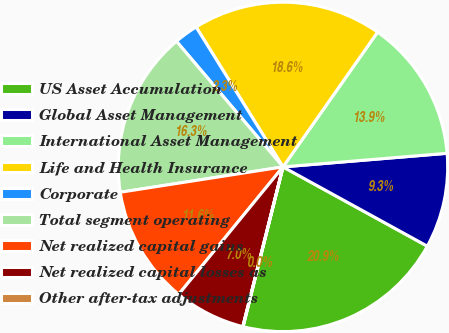Convert chart. <chart><loc_0><loc_0><loc_500><loc_500><pie_chart><fcel>US Asset Accumulation<fcel>Global Asset Management<fcel>International Asset Management<fcel>Life and Health Insurance<fcel>Corporate<fcel>Total segment operating<fcel>Net realized capital gains<fcel>Net realized capital losses as<fcel>Other after-tax adjustments<nl><fcel>20.91%<fcel>9.31%<fcel>13.95%<fcel>18.59%<fcel>2.35%<fcel>16.27%<fcel>11.63%<fcel>6.99%<fcel>0.03%<nl></chart> 